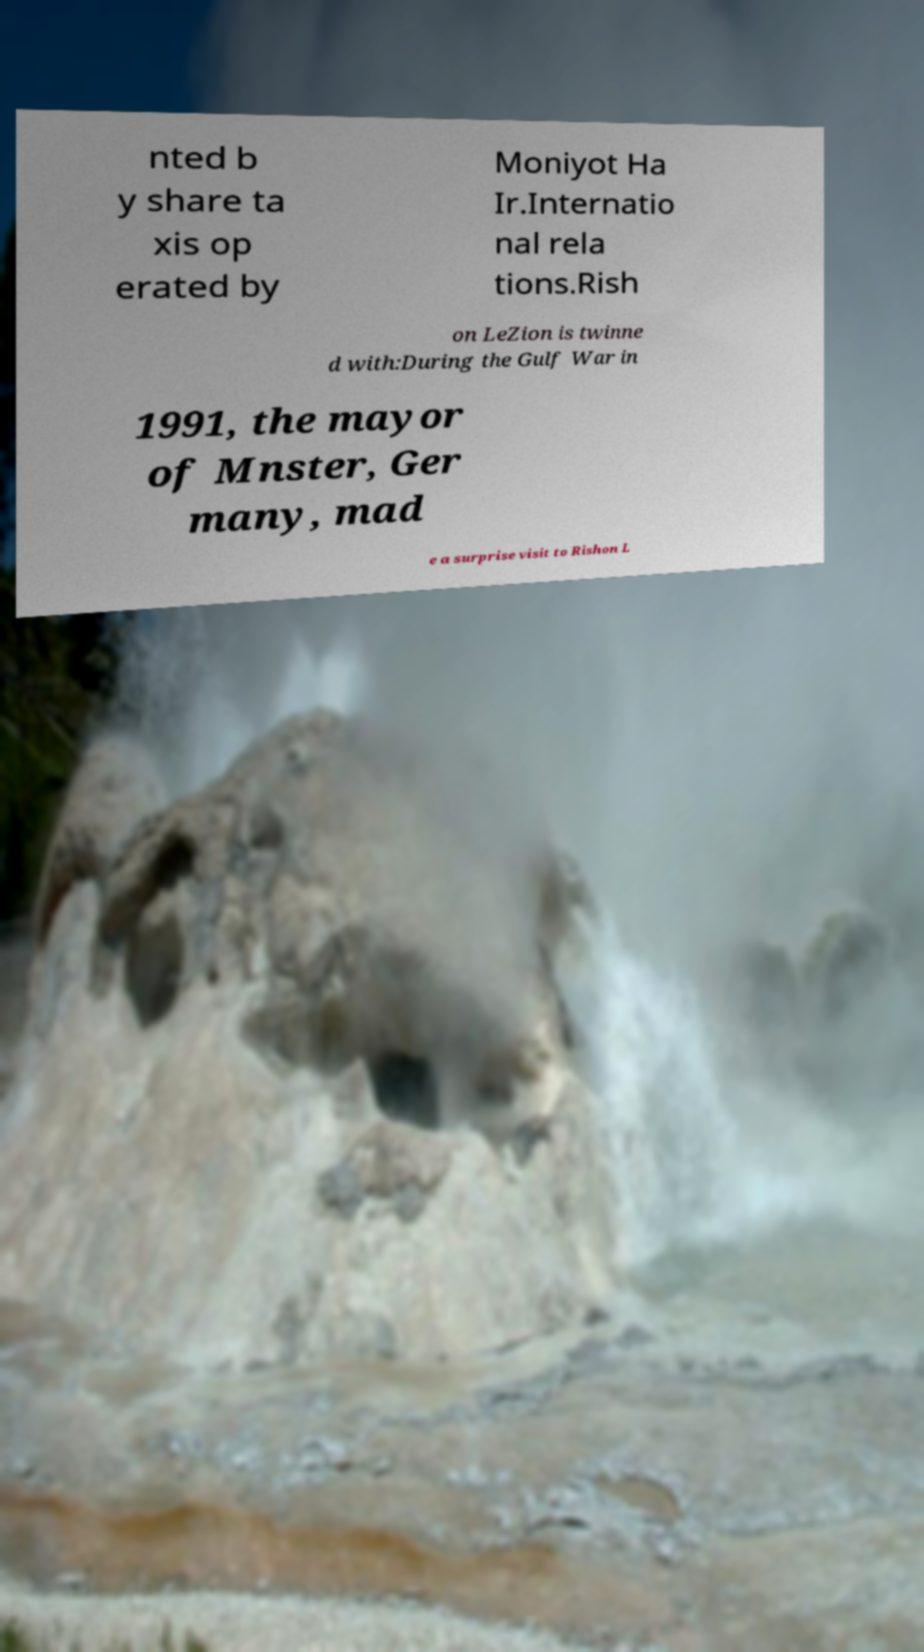Could you assist in decoding the text presented in this image and type it out clearly? nted b y share ta xis op erated by Moniyot Ha Ir.Internatio nal rela tions.Rish on LeZion is twinne d with:During the Gulf War in 1991, the mayor of Mnster, Ger many, mad e a surprise visit to Rishon L 